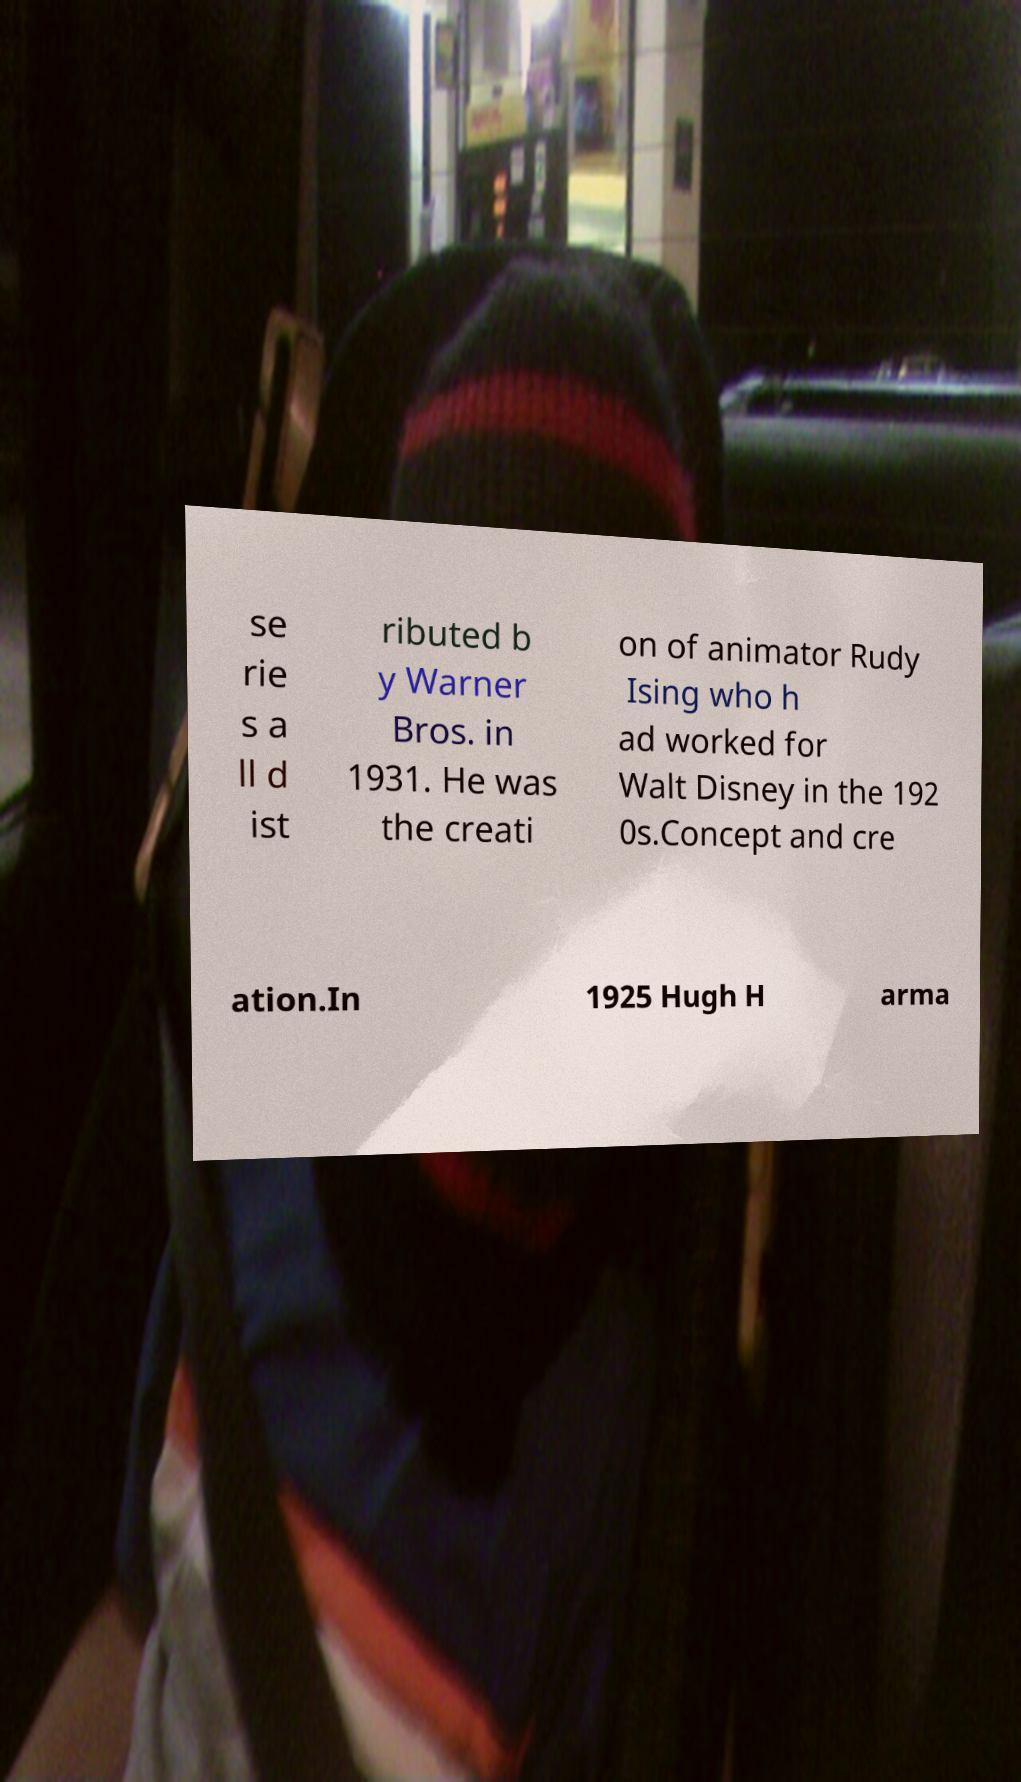Please identify and transcribe the text found in this image. se rie s a ll d ist ributed b y Warner Bros. in 1931. He was the creati on of animator Rudy Ising who h ad worked for Walt Disney in the 192 0s.Concept and cre ation.In 1925 Hugh H arma 